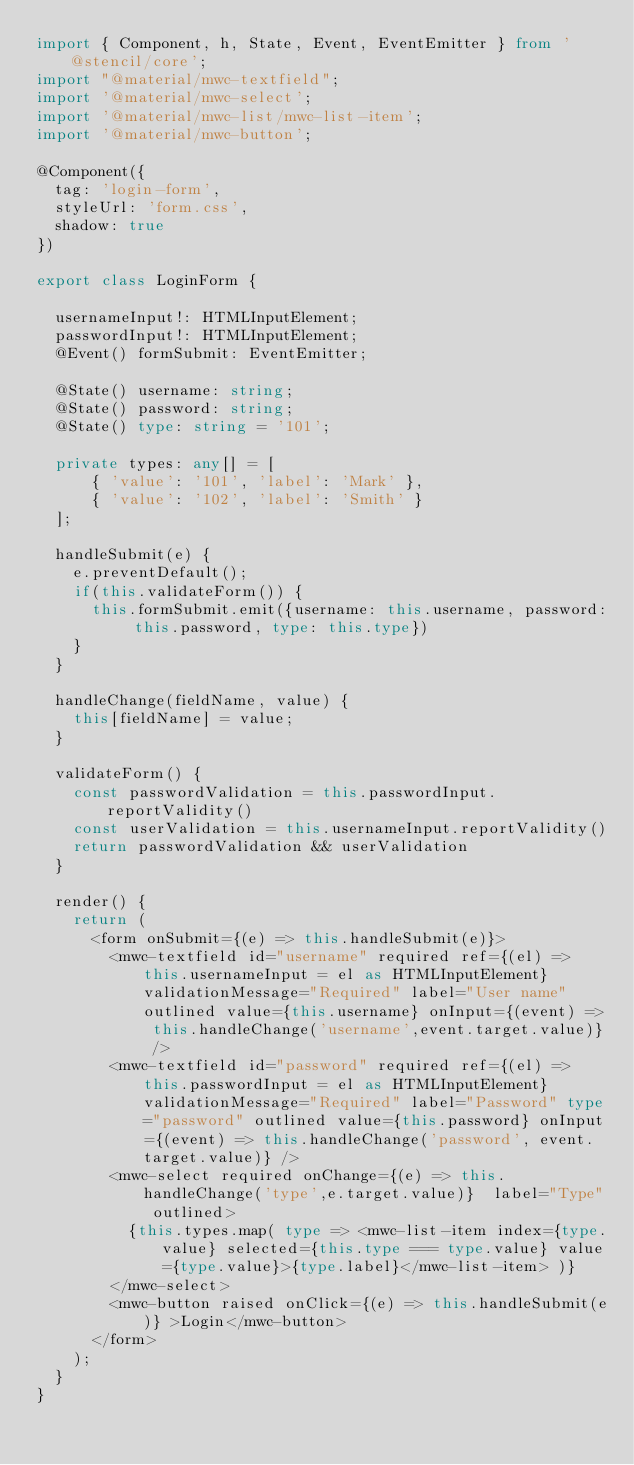<code> <loc_0><loc_0><loc_500><loc_500><_TypeScript_>import { Component, h, State, Event, EventEmitter } from '@stencil/core';
import "@material/mwc-textfield";
import '@material/mwc-select';
import '@material/mwc-list/mwc-list-item';
import '@material/mwc-button';

@Component({
  tag: 'login-form',
  styleUrl: 'form.css',
  shadow: true
})

export class LoginForm {

  usernameInput!: HTMLInputElement;
  passwordInput!: HTMLInputElement;
  @Event() formSubmit: EventEmitter;

  @State() username: string;
  @State() password: string;
  @State() type: string = '101';

  private types: any[] = [
      { 'value': '101', 'label': 'Mark' },
      { 'value': '102', 'label': 'Smith' }
  ];

  handleSubmit(e) {
    e.preventDefault();
    if(this.validateForm()) {
      this.formSubmit.emit({username: this.username, password: this.password, type: this.type})
    }
  }

  handleChange(fieldName, value) {
    this[fieldName] = value;
  }

  validateForm() {
    const passwordValidation = this.passwordInput.reportValidity()
    const userValidation = this.usernameInput.reportValidity()
    return passwordValidation && userValidation 
  }

  render() {
    return (
      <form onSubmit={(e) => this.handleSubmit(e)}>
        <mwc-textfield id="username" required ref={(el) => this.usernameInput = el as HTMLInputElement} validationMessage="Required" label="User name" outlined value={this.username} onInput={(event) => this.handleChange('username',event.target.value)} />
        <mwc-textfield id="password" required ref={(el) => this.passwordInput = el as HTMLInputElement} validationMessage="Required" label="Password" type="password" outlined value={this.password} onInput={(event) => this.handleChange('password', event.target.value)} />
        <mwc-select required onChange={(e) => this.handleChange('type',e.target.value)}  label="Type" outlined>
          {this.types.map( type => <mwc-list-item index={type.value} selected={this.type === type.value} value={type.value}>{type.label}</mwc-list-item> )}
        </mwc-select>
        <mwc-button raised onClick={(e) => this.handleSubmit(e)} >Login</mwc-button>
      </form>
    );
  }
}</code> 